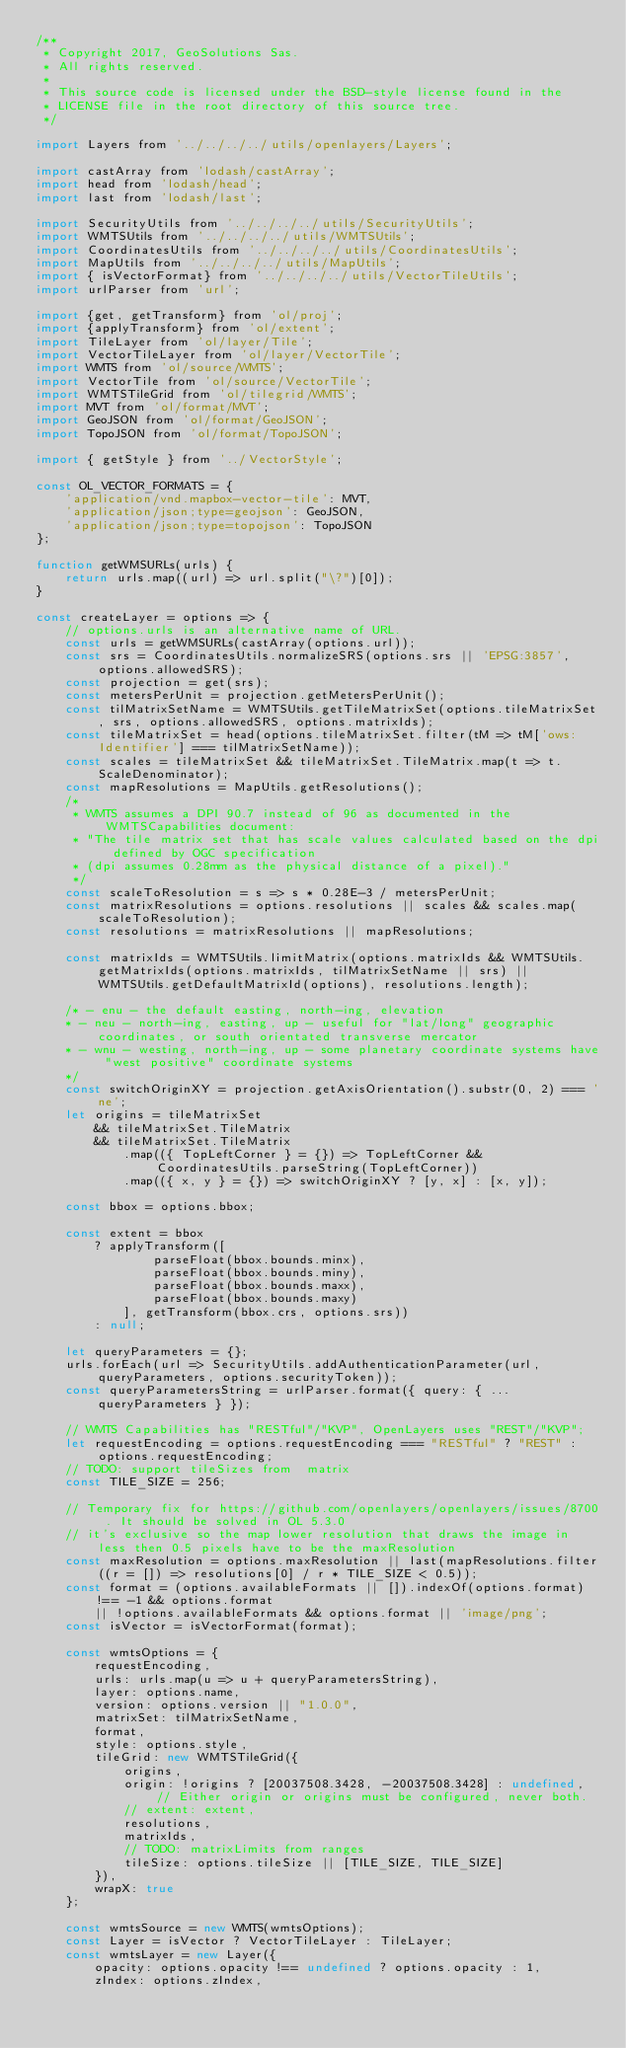Convert code to text. <code><loc_0><loc_0><loc_500><loc_500><_JavaScript_>/**
 * Copyright 2017, GeoSolutions Sas.
 * All rights reserved.
 *
 * This source code is licensed under the BSD-style license found in the
 * LICENSE file in the root directory of this source tree.
 */

import Layers from '../../../../utils/openlayers/Layers';

import castArray from 'lodash/castArray';
import head from 'lodash/head';
import last from 'lodash/last';

import SecurityUtils from '../../../../utils/SecurityUtils';
import WMTSUtils from '../../../../utils/WMTSUtils';
import CoordinatesUtils from '../../../../utils/CoordinatesUtils';
import MapUtils from '../../../../utils/MapUtils';
import { isVectorFormat} from '../../../../utils/VectorTileUtils';
import urlParser from 'url';

import {get, getTransform} from 'ol/proj';
import {applyTransform} from 'ol/extent';
import TileLayer from 'ol/layer/Tile';
import VectorTileLayer from 'ol/layer/VectorTile';
import WMTS from 'ol/source/WMTS';
import VectorTile from 'ol/source/VectorTile';
import WMTSTileGrid from 'ol/tilegrid/WMTS';
import MVT from 'ol/format/MVT';
import GeoJSON from 'ol/format/GeoJSON';
import TopoJSON from 'ol/format/TopoJSON';

import { getStyle } from '../VectorStyle';

const OL_VECTOR_FORMATS = {
    'application/vnd.mapbox-vector-tile': MVT,
    'application/json;type=geojson': GeoJSON,
    'application/json;type=topojson': TopoJSON
};

function getWMSURLs(urls) {
    return urls.map((url) => url.split("\?")[0]);
}

const createLayer = options => {
    // options.urls is an alternative name of URL.
    const urls = getWMSURLs(castArray(options.url));
    const srs = CoordinatesUtils.normalizeSRS(options.srs || 'EPSG:3857', options.allowedSRS);
    const projection = get(srs);
    const metersPerUnit = projection.getMetersPerUnit();
    const tilMatrixSetName = WMTSUtils.getTileMatrixSet(options.tileMatrixSet, srs, options.allowedSRS, options.matrixIds);
    const tileMatrixSet = head(options.tileMatrixSet.filter(tM => tM['ows:Identifier'] === tilMatrixSetName));
    const scales = tileMatrixSet && tileMatrixSet.TileMatrix.map(t => t.ScaleDenominator);
    const mapResolutions = MapUtils.getResolutions();
    /*
     * WMTS assumes a DPI 90.7 instead of 96 as documented in the WMTSCapabilities document:
     * "The tile matrix set that has scale values calculated based on the dpi defined by OGC specification
     * (dpi assumes 0.28mm as the physical distance of a pixel)."
     */
    const scaleToResolution = s => s * 0.28E-3 / metersPerUnit;
    const matrixResolutions = options.resolutions || scales && scales.map(scaleToResolution);
    const resolutions = matrixResolutions || mapResolutions;

    const matrixIds = WMTSUtils.limitMatrix(options.matrixIds && WMTSUtils.getMatrixIds(options.matrixIds, tilMatrixSetName || srs) || WMTSUtils.getDefaultMatrixId(options), resolutions.length);

    /* - enu - the default easting, north-ing, elevation
    * - neu - north-ing, easting, up - useful for "lat/long" geographic coordinates, or south orientated transverse mercator
    * - wnu - westing, north-ing, up - some planetary coordinate systems have "west positive" coordinate systems
    */
    const switchOriginXY = projection.getAxisOrientation().substr(0, 2) === 'ne';
    let origins = tileMatrixSet
        && tileMatrixSet.TileMatrix
        && tileMatrixSet.TileMatrix
            .map(({ TopLeftCorner } = {}) => TopLeftCorner && CoordinatesUtils.parseString(TopLeftCorner))
            .map(({ x, y } = {}) => switchOriginXY ? [y, x] : [x, y]);

    const bbox = options.bbox;

    const extent = bbox
        ? applyTransform([
                parseFloat(bbox.bounds.minx),
                parseFloat(bbox.bounds.miny),
                parseFloat(bbox.bounds.maxx),
                parseFloat(bbox.bounds.maxy)
            ], getTransform(bbox.crs, options.srs))
        : null;

    let queryParameters = {};
    urls.forEach(url => SecurityUtils.addAuthenticationParameter(url, queryParameters, options.securityToken));
    const queryParametersString = urlParser.format({ query: { ...queryParameters } });

    // WMTS Capabilities has "RESTful"/"KVP", OpenLayers uses "REST"/"KVP";
    let requestEncoding = options.requestEncoding === "RESTful" ? "REST" : options.requestEncoding;
    // TODO: support tileSizes from  matrix
    const TILE_SIZE = 256;

    // Temporary fix for https://github.com/openlayers/openlayers/issues/8700 . It should be solved in OL 5.3.0
    // it's exclusive so the map lower resolution that draws the image in less then 0.5 pixels have to be the maxResolution
    const maxResolution = options.maxResolution || last(mapResolutions.filter((r = []) => resolutions[0] / r * TILE_SIZE < 0.5));
    const format = (options.availableFormats || []).indexOf(options.format) !== -1 && options.format
        || !options.availableFormats && options.format || 'image/png';
    const isVector = isVectorFormat(format);

    const wmtsOptions = {
        requestEncoding,
        urls: urls.map(u => u + queryParametersString),
        layer: options.name,
        version: options.version || "1.0.0",
        matrixSet: tilMatrixSetName,
        format,
        style: options.style,
        tileGrid: new WMTSTileGrid({
            origins,
            origin: !origins ? [20037508.3428, -20037508.3428] : undefined, // Either origin or origins must be configured, never both.
            // extent: extent,
            resolutions,
            matrixIds,
            // TODO: matrixLimits from ranges
            tileSize: options.tileSize || [TILE_SIZE, TILE_SIZE]
        }),
        wrapX: true
    };

    const wmtsSource = new WMTS(wmtsOptions);
    const Layer = isVector ? VectorTileLayer : TileLayer;
    const wmtsLayer = new Layer({
        opacity: options.opacity !== undefined ? options.opacity : 1,
        zIndex: options.zIndex,</code> 